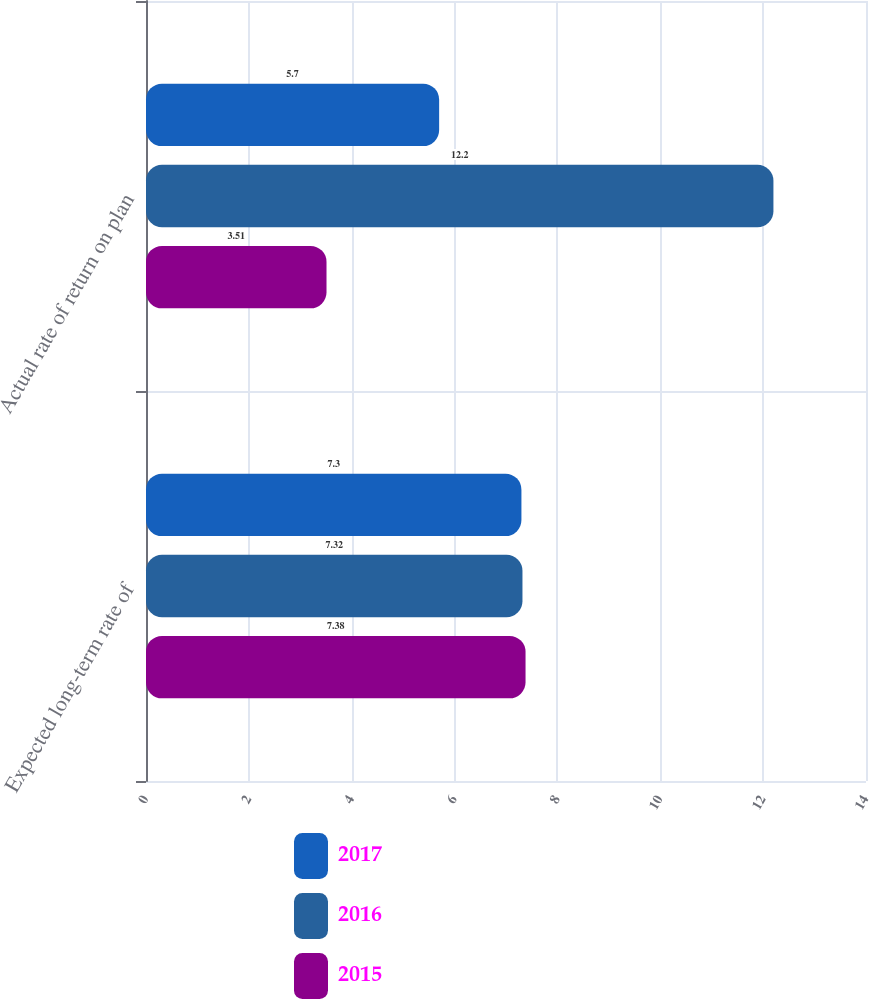<chart> <loc_0><loc_0><loc_500><loc_500><stacked_bar_chart><ecel><fcel>Expected long-term rate of<fcel>Actual rate of return on plan<nl><fcel>2017<fcel>7.3<fcel>5.7<nl><fcel>2016<fcel>7.32<fcel>12.2<nl><fcel>2015<fcel>7.38<fcel>3.51<nl></chart> 